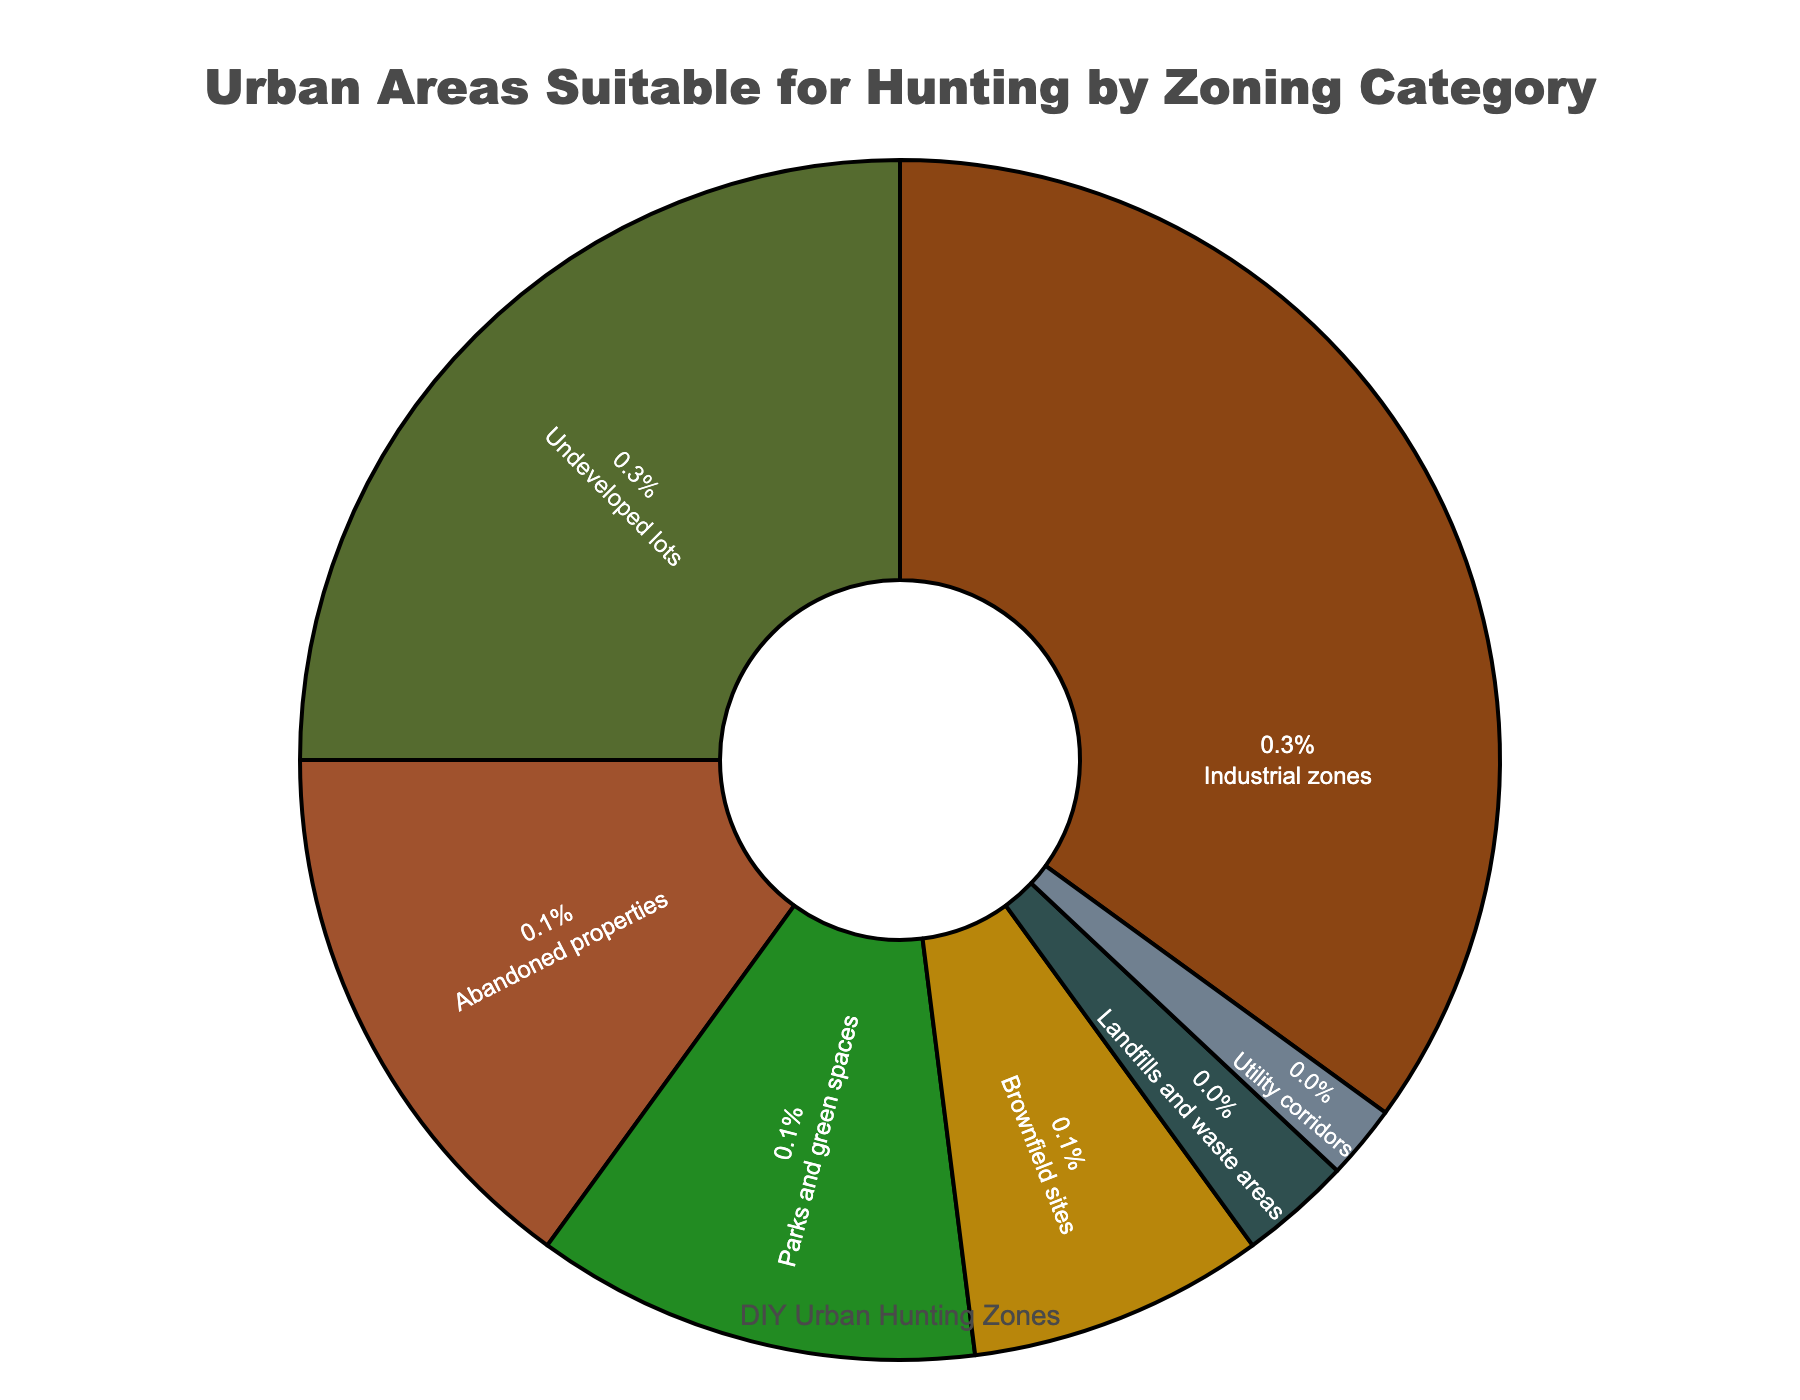What percentage of urban areas suitable for hunting are in industrial zones? Identify the portion of the pie chart labeled "Industrial zones" and read the percentage value displayed within this segment.
Answer: 35% Which category has the smallest percentage of urban areas suitable for hunting? Look at all the segments in the pie chart and find the label with the smallest percentage value.
Answer: Utility corridors How much more suitable hunting area do industrial zones have compared to brownfield sites? Subtract the percentage of brownfield sites from the percentage of industrial zones (35% - 8%).
Answer: 27% Are abandoned properties or parks and green spaces more suitable for hunting, and by how much? Compare the percentages for abandoned properties (15%) and parks and green spaces (12%). The difference can be calculated by subtracting 12% from 15%.
Answer: Abandoned properties by 3% What is the combined percentage of urban areas suitable for hunting in undeveloped lots and abandoned properties? Add the percentages of undeveloped lots (25%) and abandoned properties (15%) (25% + 15%).
Answer: 40% Is the percentage of urban areas suitable for hunting in landfills and waste areas more, less, or equal to that in utility corridors? Compare the percentages for landfills and waste areas (3%) and utility corridors (2%).
Answer: More What percentage of urban areas suitable for hunting do brownfield sites and landfills and waste areas collectively account for? Add the percentages of brownfield sites (8%) and landfills and waste areas (3%) (8% + 3%).
Answer: 11% Which sector, parks and green spaces or undeveloped lots, has a higher suitability for hunting and by how much? Compare the percentages for parks and green spaces (12%) and undeveloped lots (25%) and subtract the smaller percentage from the larger one (25% - 12%).
Answer: Undeveloped lots by 13% Are the percentages of urban areas suitable for hunting in industrial zones and undeveloped lots together greater than 50%? Check the sum of percentages for industrial zones (35%) and undeveloped lots (25%) and see if it's greater than 50% (35% + 25%).
Answer: Yes What's the combined percentage of urban areas suitable for hunting in categories other than industrial zones, undeveloped lots, and abandoned properties? Add the percentages of all the other categories (Parks and green spaces (12%) + Brownfield sites (8%) + Landfills and waste areas (3%) + Utility corridors (2%)) (12% + 8% + 3% + 2%).
Answer: 25% 